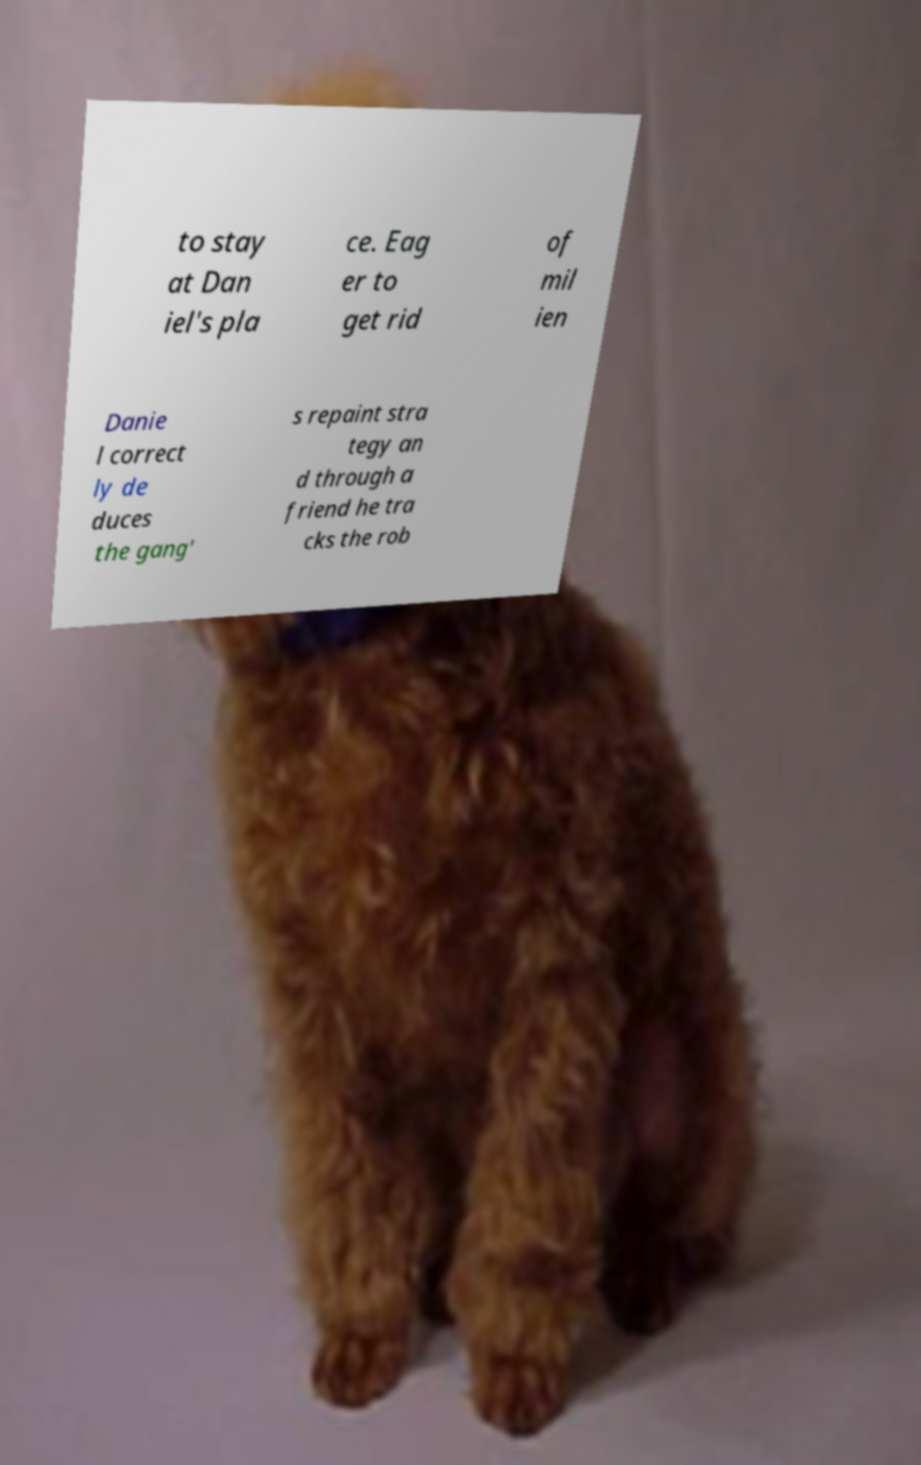Could you assist in decoding the text presented in this image and type it out clearly? to stay at Dan iel's pla ce. Eag er to get rid of mil ien Danie l correct ly de duces the gang' s repaint stra tegy an d through a friend he tra cks the rob 